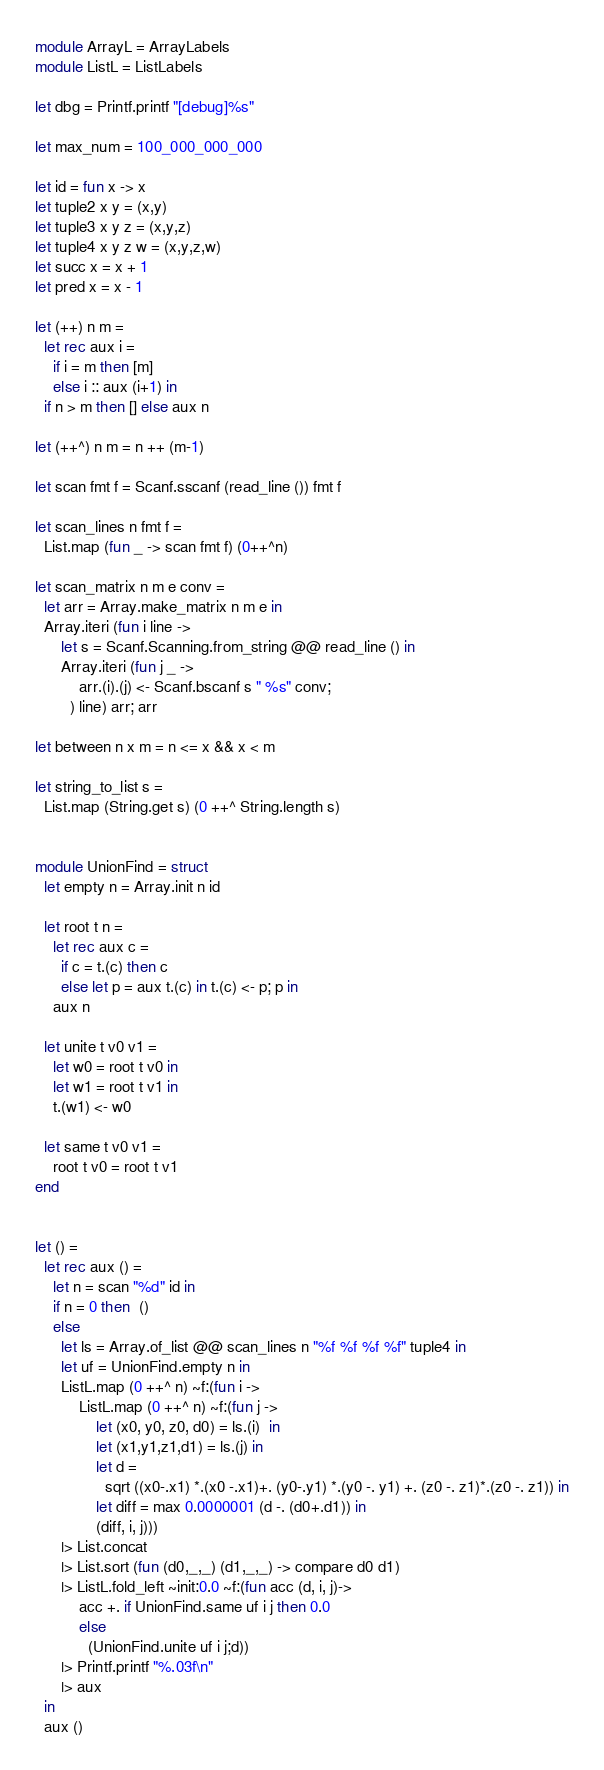Convert code to text. <code><loc_0><loc_0><loc_500><loc_500><_OCaml_>module ArrayL = ArrayLabels
module ListL = ListLabels

let dbg = Printf.printf "[debug]%s"

let max_num = 100_000_000_000

let id = fun x -> x
let tuple2 x y = (x,y)
let tuple3 x y z = (x,y,z)
let tuple4 x y z w = (x,y,z,w)
let succ x = x + 1
let pred x = x - 1

let (++) n m =
  let rec aux i =
    if i = m then [m]
    else i :: aux (i+1) in
  if n > m then [] else aux n

let (++^) n m = n ++ (m-1)

let scan fmt f = Scanf.sscanf (read_line ()) fmt f

let scan_lines n fmt f =
  List.map (fun _ -> scan fmt f) (0++^n)

let scan_matrix n m e conv =
  let arr = Array.make_matrix n m e in
  Array.iteri (fun i line ->
      let s = Scanf.Scanning.from_string @@ read_line () in
      Array.iteri (fun j _ ->
          arr.(i).(j) <- Scanf.bscanf s " %s" conv;
        ) line) arr; arr

let between n x m = n <= x && x < m

let string_to_list s =
  List.map (String.get s) (0 ++^ String.length s)


module UnionFind = struct
  let empty n = Array.init n id

  let root t n =
    let rec aux c =
      if c = t.(c) then c
      else let p = aux t.(c) in t.(c) <- p; p in
    aux n

  let unite t v0 v1 =
    let w0 = root t v0 in
    let w1 = root t v1 in
    t.(w1) <- w0

  let same t v0 v1 =
    root t v0 = root t v1
end


let () =
  let rec aux () =
    let n = scan "%d" id in
    if n = 0 then  ()
    else
      let ls = Array.of_list @@ scan_lines n "%f %f %f %f" tuple4 in
      let uf = UnionFind.empty n in
      ListL.map (0 ++^ n) ~f:(fun i ->
          ListL.map (0 ++^ n) ~f:(fun j ->
              let (x0, y0, z0, d0) = ls.(i)  in
              let (x1,y1,z1,d1) = ls.(j) in
              let d =
                sqrt ((x0-.x1) *.(x0 -.x1)+. (y0-.y1) *.(y0 -. y1) +. (z0 -. z1)*.(z0 -. z1)) in
              let diff = max 0.0000001 (d -. (d0+.d1)) in
              (diff, i, j)))
      |> List.concat
      |> List.sort (fun (d0,_,_) (d1,_,_) -> compare d0 d1)
      |> ListL.fold_left ~init:0.0 ~f:(fun acc (d, i, j)->
          acc +. if UnionFind.same uf i j then 0.0
          else
            (UnionFind.unite uf i j;d))
      |> Printf.printf "%.03f\n"
      |> aux
  in
  aux ()

</code> 